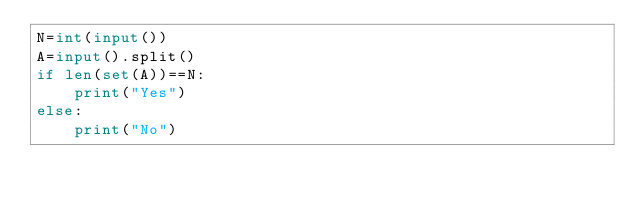<code> <loc_0><loc_0><loc_500><loc_500><_Python_>N=int(input())
A=input().split()
if len(set(A))==N:
    print("Yes")
else:
    print("No")</code> 